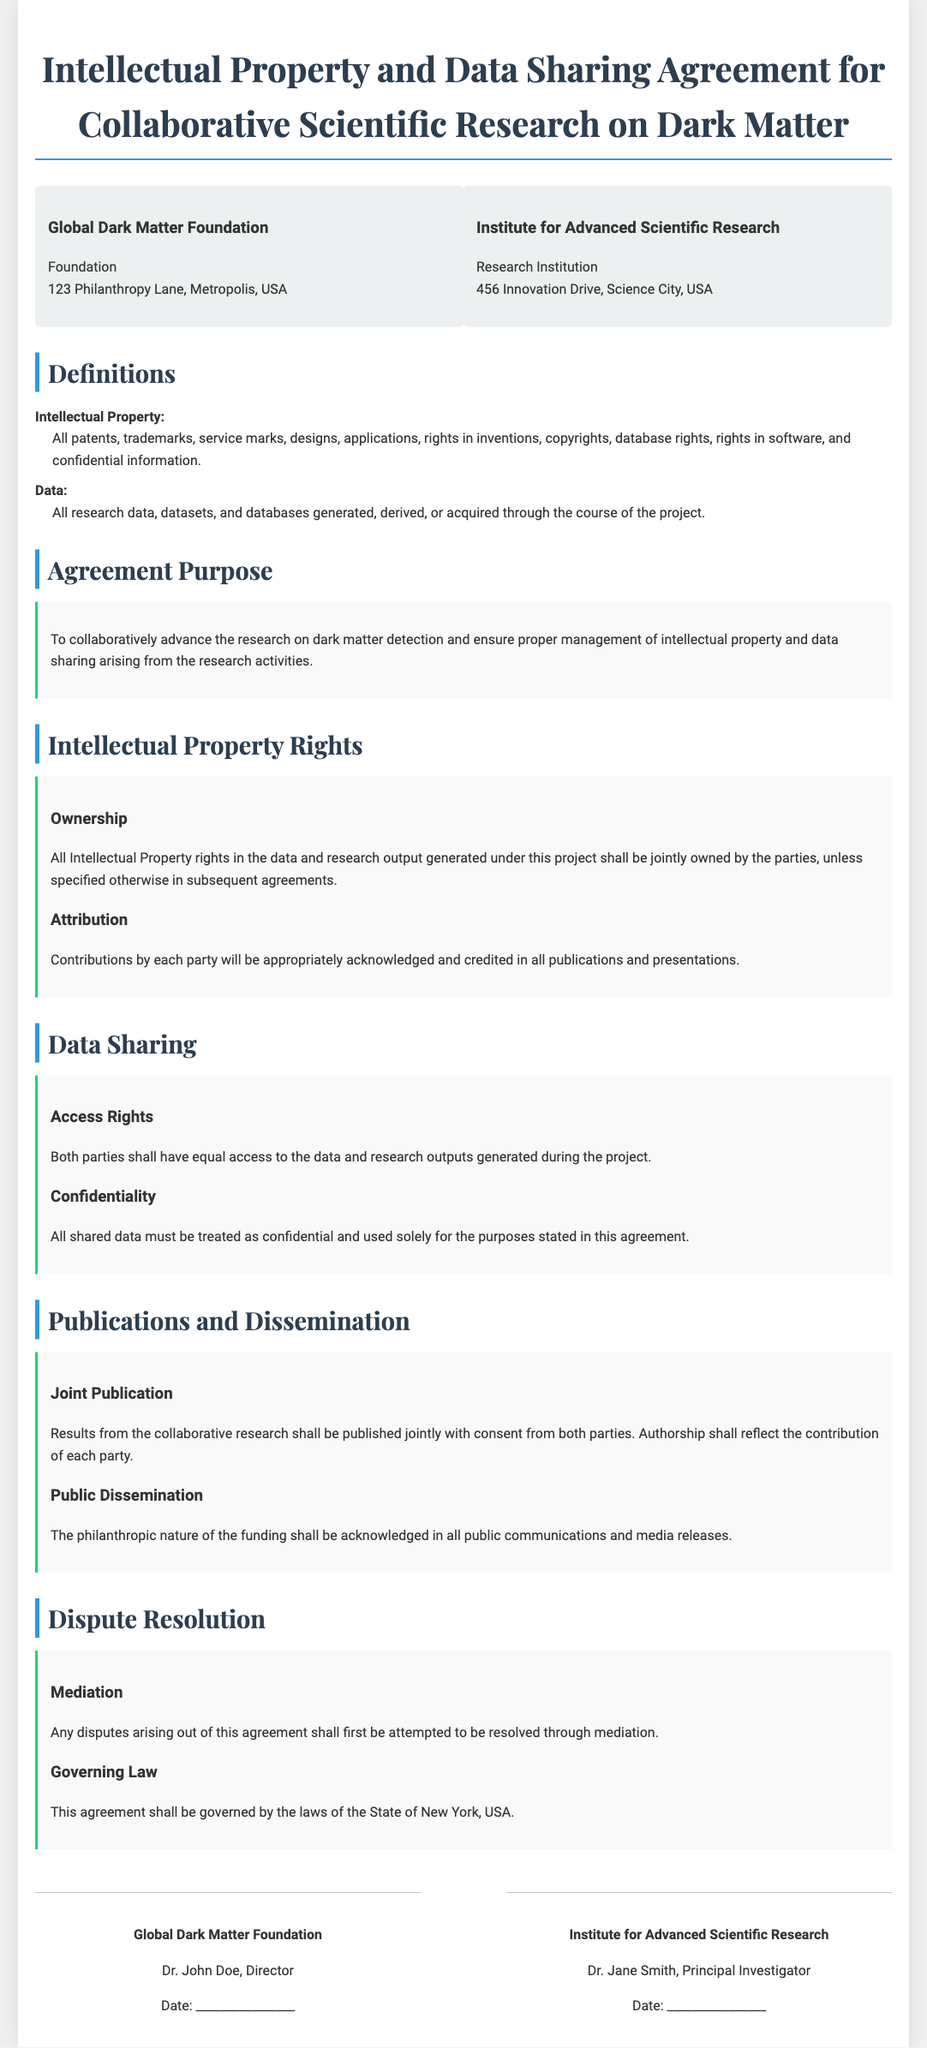What is the name of the foundation? The foundation involved in the agreement is named Global Dark Matter Foundation.
Answer: Global Dark Matter Foundation Who is the principal investigator for the Institute for Advanced Scientific Research? The principal investigator listed for the institute is Dr. Jane Smith.
Answer: Dr. Jane Smith What is the agreement's purpose? The purpose of the agreement is to collaboratively advance the research on dark matter detection and ensure proper management of intellectual property and data sharing arising from the research activities.
Answer: To collaboratively advance research on dark matter detection What must be acknowledged in all public communications? The agreement states that the philanthropic nature of the funding must be acknowledged in all public communications.
Answer: Philanthropic nature of the funding What will happen to disputes arising from this agreement? Any disputes arising out of this agreement shall first be attempted to be resolved through mediation.
Answer: Resolved through mediation In which state's laws is the agreement governed? The agreement is governed by the laws of the State of New York, USA.
Answer: State of New York How should contributions be credited in publications? Contributions by each party will be appropriately acknowledged and credited in all publications and presentations.
Answer: Appropriately acknowledged and credited What clause addresses data confidentiality? The data confidentiality clause is outlined under "Data Sharing" with specific details on handling shared data.
Answer: Data Sharing clause 